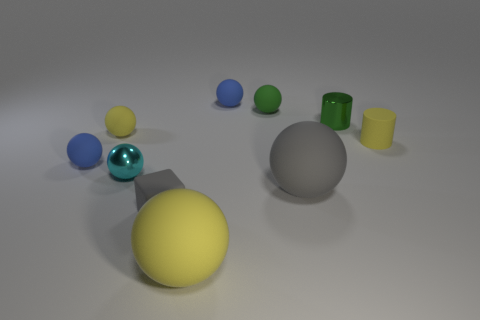What material is the small cyan thing that is the same shape as the big gray thing?
Provide a succinct answer. Metal. How many objects are either small objects left of the cube or tiny yellow objects left of the tiny green rubber sphere?
Your answer should be very brief. 3. There is a tiny block; is its color the same as the big rubber ball behind the tiny gray block?
Offer a terse response. Yes. What is the shape of the small gray object that is made of the same material as the yellow cylinder?
Make the answer very short. Cube. How many small cubes are there?
Offer a terse response. 1. How many objects are yellow rubber objects that are behind the large yellow thing or yellow cylinders?
Give a very brief answer. 2. There is a large thing left of the tiny green sphere; is its color the same as the small rubber cylinder?
Make the answer very short. Yes. What number of other objects are there of the same color as the rubber block?
Offer a terse response. 1. How many big things are either cylinders or green metal objects?
Your response must be concise. 0. Is the number of green spheres greater than the number of tiny green metal cubes?
Offer a terse response. Yes. 